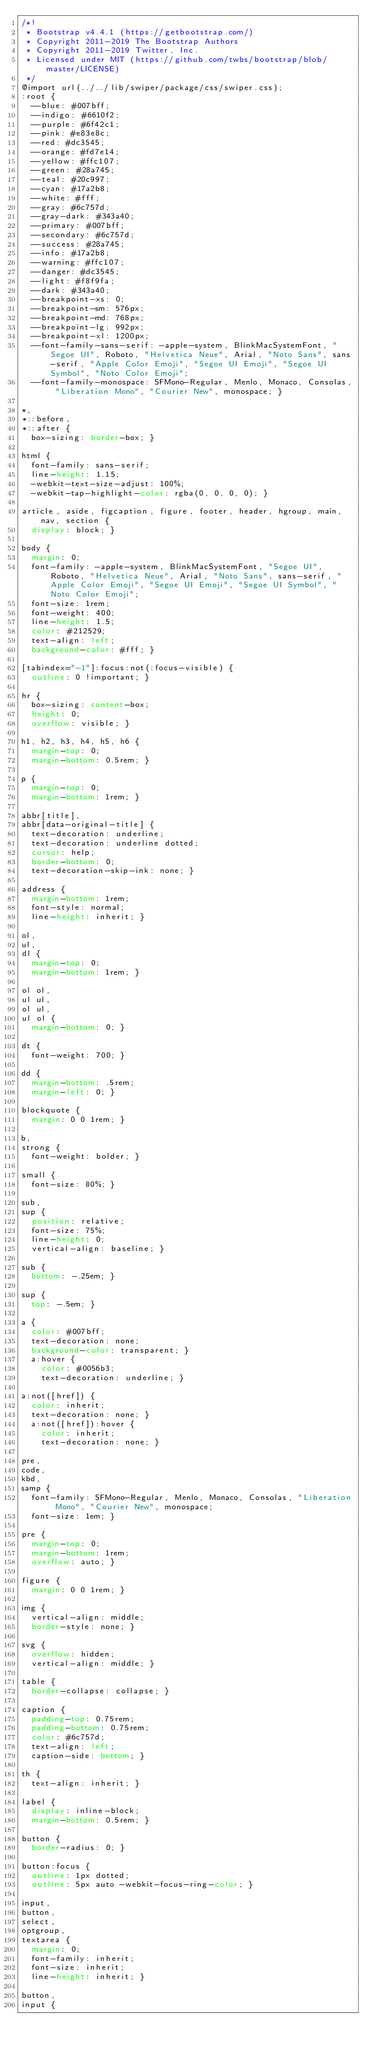Convert code to text. <code><loc_0><loc_0><loc_500><loc_500><_CSS_>/*!
 * Bootstrap v4.4.1 (https://getbootstrap.com/)
 * Copyright 2011-2019 The Bootstrap Authors
 * Copyright 2011-2019 Twitter, Inc.
 * Licensed under MIT (https://github.com/twbs/bootstrap/blob/master/LICENSE)
 */
@import url(../../lib/swiper/package/css/swiper.css);
:root {
  --blue: #007bff;
  --indigo: #6610f2;
  --purple: #6f42c1;
  --pink: #e83e8c;
  --red: #dc3545;
  --orange: #fd7e14;
  --yellow: #ffc107;
  --green: #28a745;
  --teal: #20c997;
  --cyan: #17a2b8;
  --white: #fff;
  --gray: #6c757d;
  --gray-dark: #343a40;
  --primary: #007bff;
  --secondary: #6c757d;
  --success: #28a745;
  --info: #17a2b8;
  --warning: #ffc107;
  --danger: #dc3545;
  --light: #f8f9fa;
  --dark: #343a40;
  --breakpoint-xs: 0;
  --breakpoint-sm: 576px;
  --breakpoint-md: 768px;
  --breakpoint-lg: 992px;
  --breakpoint-xl: 1200px;
  --font-family-sans-serif: -apple-system, BlinkMacSystemFont, "Segoe UI", Roboto, "Helvetica Neue", Arial, "Noto Sans", sans-serif, "Apple Color Emoji", "Segoe UI Emoji", "Segoe UI Symbol", "Noto Color Emoji";
  --font-family-monospace: SFMono-Regular, Menlo, Monaco, Consolas, "Liberation Mono", "Courier New", monospace; }

*,
*::before,
*::after {
  box-sizing: border-box; }

html {
  font-family: sans-serif;
  line-height: 1.15;
  -webkit-text-size-adjust: 100%;
  -webkit-tap-highlight-color: rgba(0, 0, 0, 0); }

article, aside, figcaption, figure, footer, header, hgroup, main, nav, section {
  display: block; }

body {
  margin: 0;
  font-family: -apple-system, BlinkMacSystemFont, "Segoe UI", Roboto, "Helvetica Neue", Arial, "Noto Sans", sans-serif, "Apple Color Emoji", "Segoe UI Emoji", "Segoe UI Symbol", "Noto Color Emoji";
  font-size: 1rem;
  font-weight: 400;
  line-height: 1.5;
  color: #212529;
  text-align: left;
  background-color: #fff; }

[tabindex="-1"]:focus:not(:focus-visible) {
  outline: 0 !important; }

hr {
  box-sizing: content-box;
  height: 0;
  overflow: visible; }

h1, h2, h3, h4, h5, h6 {
  margin-top: 0;
  margin-bottom: 0.5rem; }

p {
  margin-top: 0;
  margin-bottom: 1rem; }

abbr[title],
abbr[data-original-title] {
  text-decoration: underline;
  text-decoration: underline dotted;
  cursor: help;
  border-bottom: 0;
  text-decoration-skip-ink: none; }

address {
  margin-bottom: 1rem;
  font-style: normal;
  line-height: inherit; }

ol,
ul,
dl {
  margin-top: 0;
  margin-bottom: 1rem; }

ol ol,
ul ul,
ol ul,
ul ol {
  margin-bottom: 0; }

dt {
  font-weight: 700; }

dd {
  margin-bottom: .5rem;
  margin-left: 0; }

blockquote {
  margin: 0 0 1rem; }

b,
strong {
  font-weight: bolder; }

small {
  font-size: 80%; }

sub,
sup {
  position: relative;
  font-size: 75%;
  line-height: 0;
  vertical-align: baseline; }

sub {
  bottom: -.25em; }

sup {
  top: -.5em; }

a {
  color: #007bff;
  text-decoration: none;
  background-color: transparent; }
  a:hover {
    color: #0056b3;
    text-decoration: underline; }

a:not([href]) {
  color: inherit;
  text-decoration: none; }
  a:not([href]):hover {
    color: inherit;
    text-decoration: none; }

pre,
code,
kbd,
samp {
  font-family: SFMono-Regular, Menlo, Monaco, Consolas, "Liberation Mono", "Courier New", monospace;
  font-size: 1em; }

pre {
  margin-top: 0;
  margin-bottom: 1rem;
  overflow: auto; }

figure {
  margin: 0 0 1rem; }

img {
  vertical-align: middle;
  border-style: none; }

svg {
  overflow: hidden;
  vertical-align: middle; }

table {
  border-collapse: collapse; }

caption {
  padding-top: 0.75rem;
  padding-bottom: 0.75rem;
  color: #6c757d;
  text-align: left;
  caption-side: bottom; }

th {
  text-align: inherit; }

label {
  display: inline-block;
  margin-bottom: 0.5rem; }

button {
  border-radius: 0; }

button:focus {
  outline: 1px dotted;
  outline: 5px auto -webkit-focus-ring-color; }

input,
button,
select,
optgroup,
textarea {
  margin: 0;
  font-family: inherit;
  font-size: inherit;
  line-height: inherit; }

button,
input {</code> 